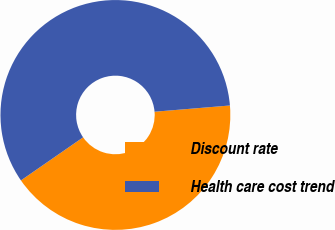Convert chart. <chart><loc_0><loc_0><loc_500><loc_500><pie_chart><fcel>Discount rate<fcel>Health care cost trend<nl><fcel>41.67%<fcel>58.33%<nl></chart> 